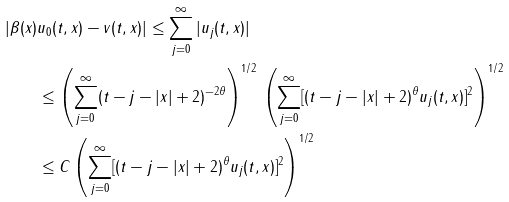<formula> <loc_0><loc_0><loc_500><loc_500>| \beta ( x ) & u _ { 0 } ( t , x ) - v ( t , x ) | \leq \sum _ { j = 0 } ^ { \infty } | u _ { j } ( t , x ) | \\ & \leq \left ( \sum _ { j = 0 } ^ { \infty } ( t - j - | x | + 2 ) ^ { - 2 \theta } \right ) ^ { 1 / 2 } \, \left ( \sum _ { j = 0 } ^ { \infty } [ ( t - j - | x | + 2 ) ^ { \theta } u _ { j } ( t , x ) ] ^ { 2 } \right ) ^ { 1 / 2 } \\ & \leq C \left ( \sum _ { j = 0 } ^ { \infty } [ ( t - j - | x | + 2 ) ^ { \theta } u _ { j } ( t , x ) ] ^ { 2 } \right ) ^ { 1 / 2 }</formula> 